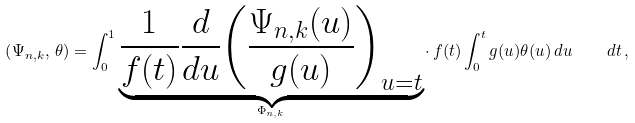Convert formula to latex. <formula><loc_0><loc_0><loc_500><loc_500>\left ( \Psi _ { n , k } , \, \theta \right ) = \int _ { 0 } ^ { 1 } \underbrace { \frac { 1 } { f ( t ) } \frac { d } { d u } { \left ( \frac { \Psi _ { n , k } ( u ) } { g ( u ) } \right ) } _ { u = t } } _ { \Phi _ { n , k } } \cdot \, f ( t ) \int _ { 0 } ^ { t } g ( u ) \theta ( u ) \, d u \quad d t \, ,</formula> 